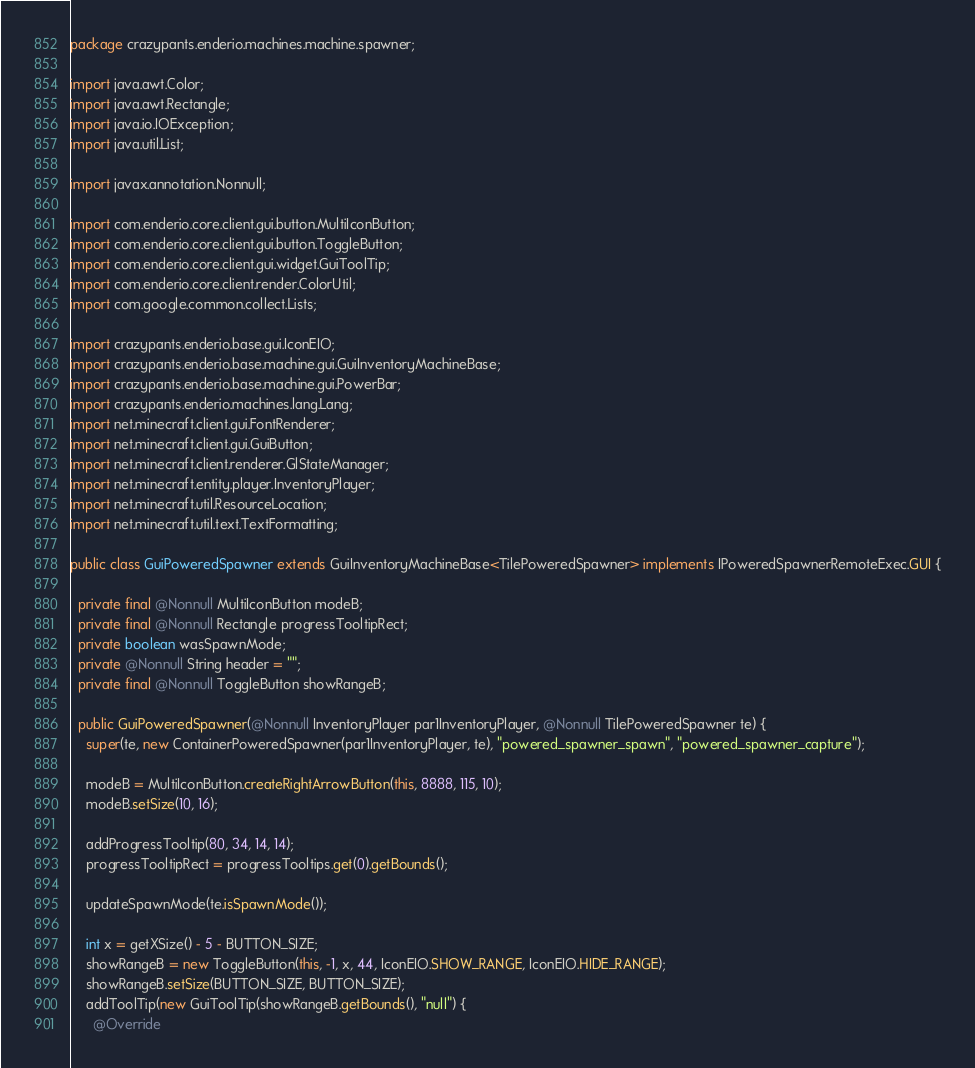Convert code to text. <code><loc_0><loc_0><loc_500><loc_500><_Java_>package crazypants.enderio.machines.machine.spawner;

import java.awt.Color;
import java.awt.Rectangle;
import java.io.IOException;
import java.util.List;

import javax.annotation.Nonnull;

import com.enderio.core.client.gui.button.MultiIconButton;
import com.enderio.core.client.gui.button.ToggleButton;
import com.enderio.core.client.gui.widget.GuiToolTip;
import com.enderio.core.client.render.ColorUtil;
import com.google.common.collect.Lists;

import crazypants.enderio.base.gui.IconEIO;
import crazypants.enderio.base.machine.gui.GuiInventoryMachineBase;
import crazypants.enderio.base.machine.gui.PowerBar;
import crazypants.enderio.machines.lang.Lang;
import net.minecraft.client.gui.FontRenderer;
import net.minecraft.client.gui.GuiButton;
import net.minecraft.client.renderer.GlStateManager;
import net.minecraft.entity.player.InventoryPlayer;
import net.minecraft.util.ResourceLocation;
import net.minecraft.util.text.TextFormatting;

public class GuiPoweredSpawner extends GuiInventoryMachineBase<TilePoweredSpawner> implements IPoweredSpawnerRemoteExec.GUI {

  private final @Nonnull MultiIconButton modeB;
  private final @Nonnull Rectangle progressTooltipRect;
  private boolean wasSpawnMode;
  private @Nonnull String header = "";
  private final @Nonnull ToggleButton showRangeB;

  public GuiPoweredSpawner(@Nonnull InventoryPlayer par1InventoryPlayer, @Nonnull TilePoweredSpawner te) {
    super(te, new ContainerPoweredSpawner(par1InventoryPlayer, te), "powered_spawner_spawn", "powered_spawner_capture");

    modeB = MultiIconButton.createRightArrowButton(this, 8888, 115, 10);
    modeB.setSize(10, 16);

    addProgressTooltip(80, 34, 14, 14);
    progressTooltipRect = progressTooltips.get(0).getBounds();

    updateSpawnMode(te.isSpawnMode());

    int x = getXSize() - 5 - BUTTON_SIZE;
    showRangeB = new ToggleButton(this, -1, x, 44, IconEIO.SHOW_RANGE, IconEIO.HIDE_RANGE);
    showRangeB.setSize(BUTTON_SIZE, BUTTON_SIZE);
    addToolTip(new GuiToolTip(showRangeB.getBounds(), "null") {
      @Override</code> 